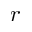<formula> <loc_0><loc_0><loc_500><loc_500>r</formula> 